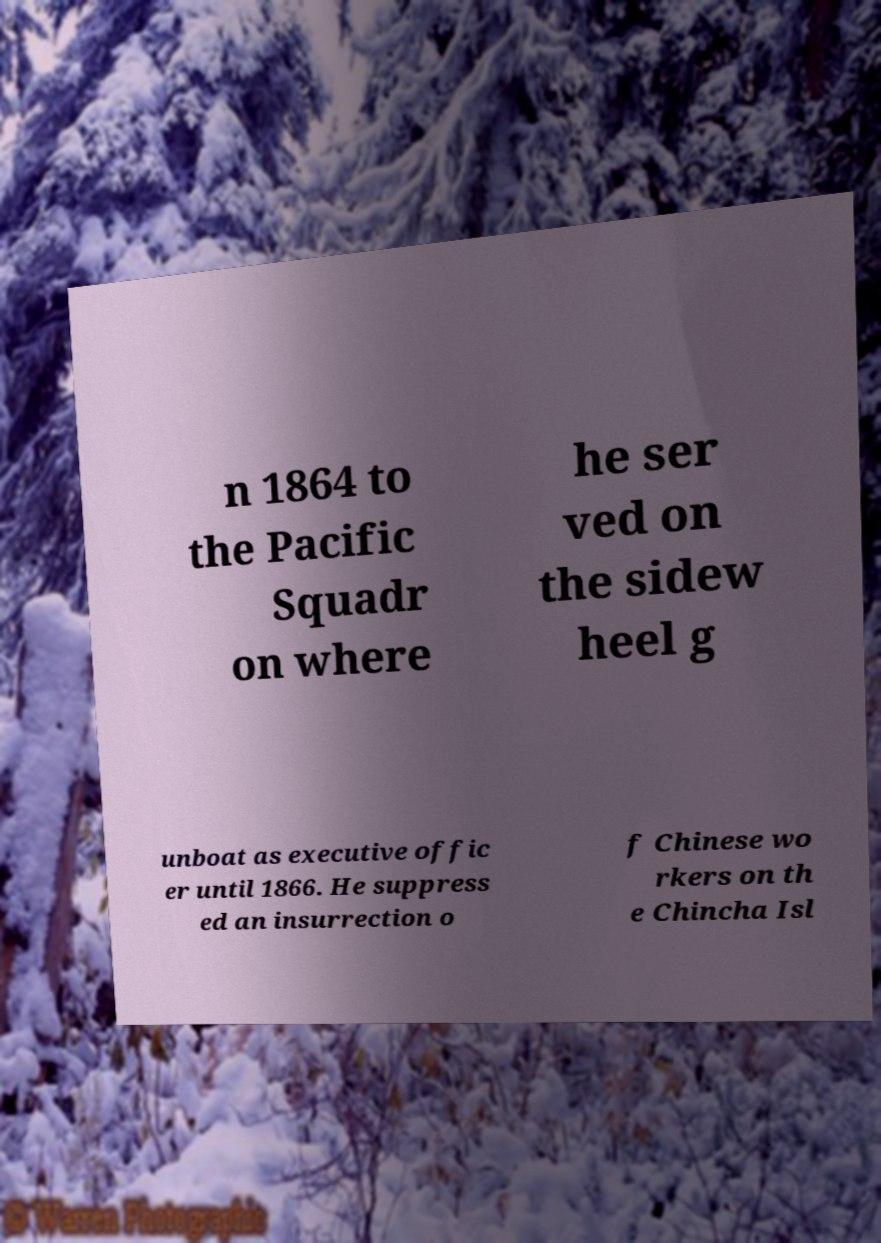Please identify and transcribe the text found in this image. n 1864 to the Pacific Squadr on where he ser ved on the sidew heel g unboat as executive offic er until 1866. He suppress ed an insurrection o f Chinese wo rkers on th e Chincha Isl 